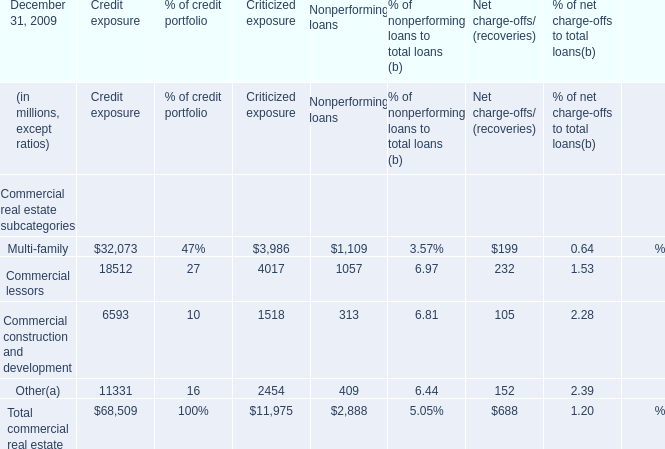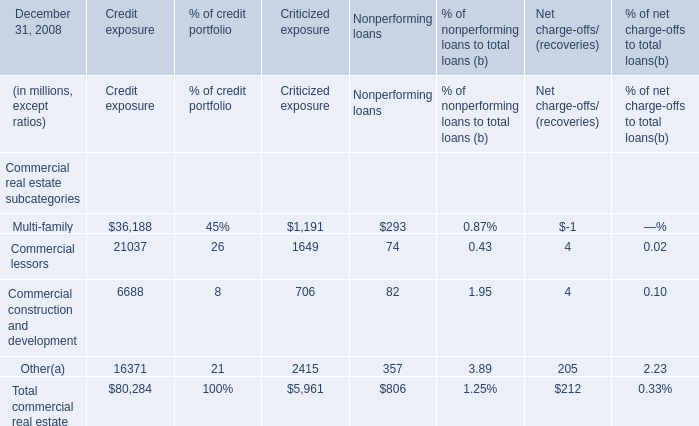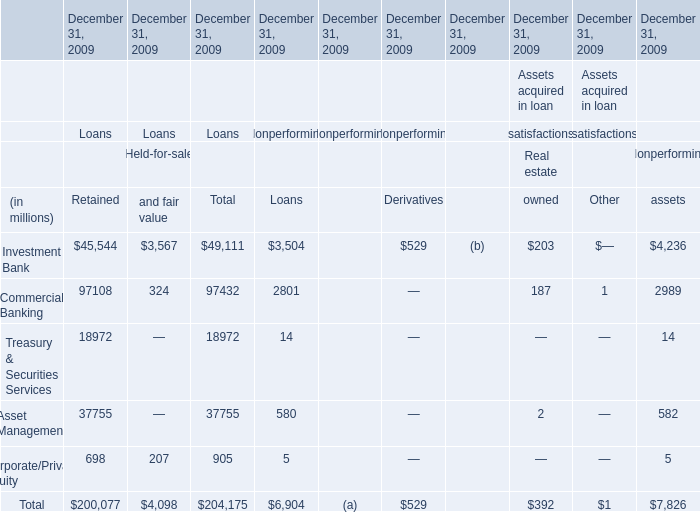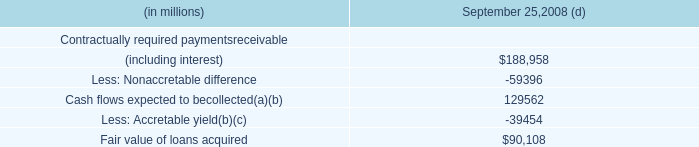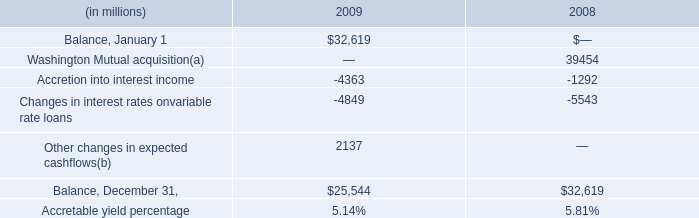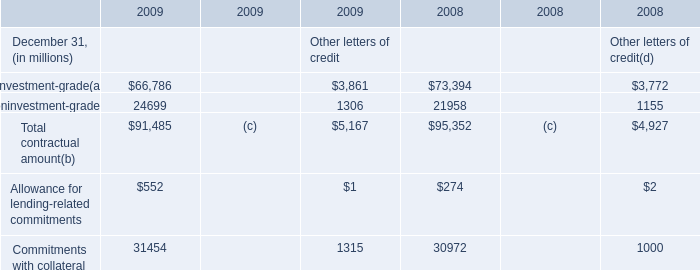In the section with the most Commercial lessors for Commercial real estate subcategories for Amount?, what is the growth rate of Commercial construction and development? 
Computations: ((18512 - 6593) / 6593)
Answer: 1.80783. 